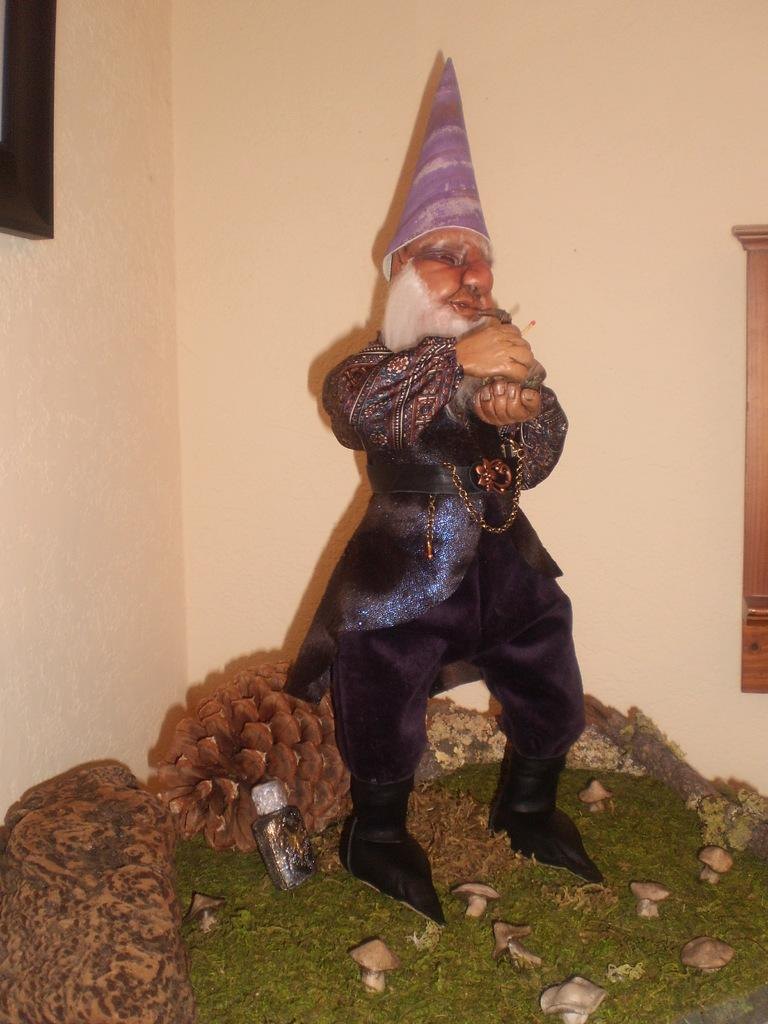What is the main subject of the image? There is a statue of a man in the image. What type of natural environment is visible in the image? There is grass in the image. What type of fungi can be seen in the image? There are mushrooms in the image. What type of container is present in the image? There is a bottle in the image. What type of objects can be seen in the image besides the statue and the bottle? There are decorative objects in the image. What can be seen on the wall in the background of the image? There are objects on the wall in the background of the image. How many kittens are playing with the mushrooms in the image? There are no kittens present in the image; it only features a statue of a man, grass, mushrooms, a bottle, decorative objects, and objects on the wall in the background. What type of bread can be seen in the image? There is no bread present in the image. 